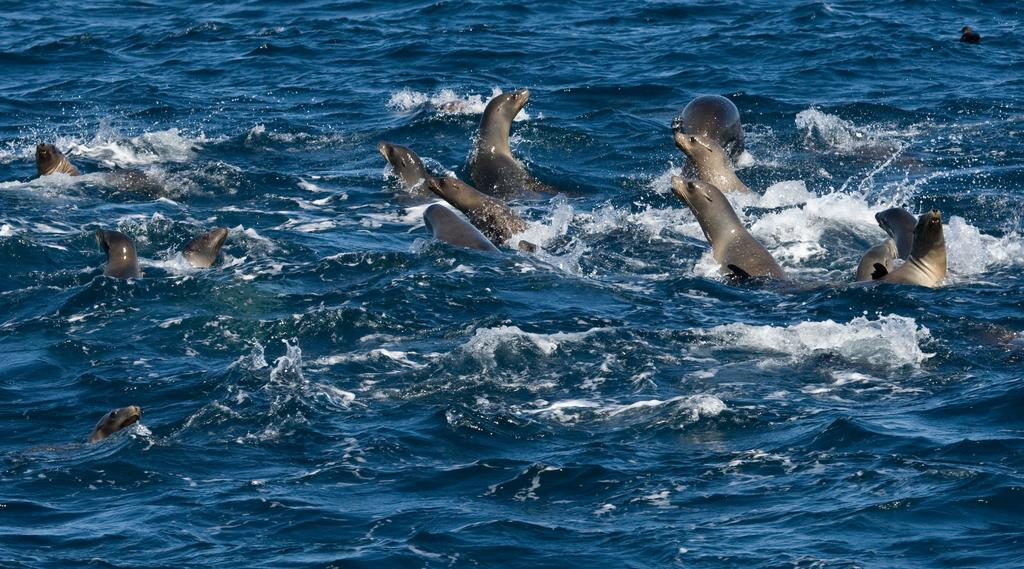What animals are present in the image? There are seals in the image. What are the seals doing in the image? The seals are swimming in the water. What is the position of the basketball in the image? There is no basketball present in the image. 